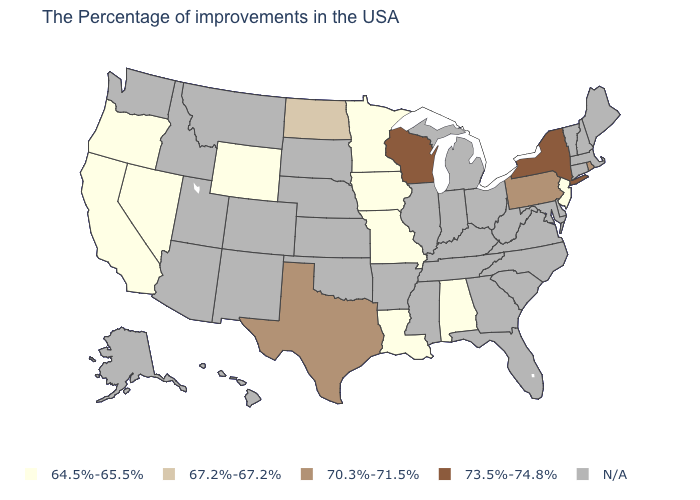Does Wisconsin have the highest value in the USA?
Keep it brief. Yes. What is the value of New Hampshire?
Give a very brief answer. N/A. What is the value of Virginia?
Concise answer only. N/A. What is the value of Arkansas?
Short answer required. N/A. Name the states that have a value in the range 67.2%-67.2%?
Write a very short answer. North Dakota. What is the lowest value in the MidWest?
Short answer required. 64.5%-65.5%. Among the states that border Iowa , which have the highest value?
Concise answer only. Wisconsin. What is the value of Idaho?
Give a very brief answer. N/A. Name the states that have a value in the range N/A?
Give a very brief answer. Maine, Massachusetts, New Hampshire, Vermont, Connecticut, Delaware, Maryland, Virginia, North Carolina, South Carolina, West Virginia, Ohio, Florida, Georgia, Michigan, Kentucky, Indiana, Tennessee, Illinois, Mississippi, Arkansas, Kansas, Nebraska, Oklahoma, South Dakota, Colorado, New Mexico, Utah, Montana, Arizona, Idaho, Washington, Alaska, Hawaii. What is the value of Pennsylvania?
Keep it brief. 70.3%-71.5%. Does the map have missing data?
Keep it brief. Yes. Among the states that border Nevada , which have the lowest value?
Be succinct. California, Oregon. What is the value of South Carolina?
Quick response, please. N/A. Does New York have the highest value in the USA?
Concise answer only. Yes. 